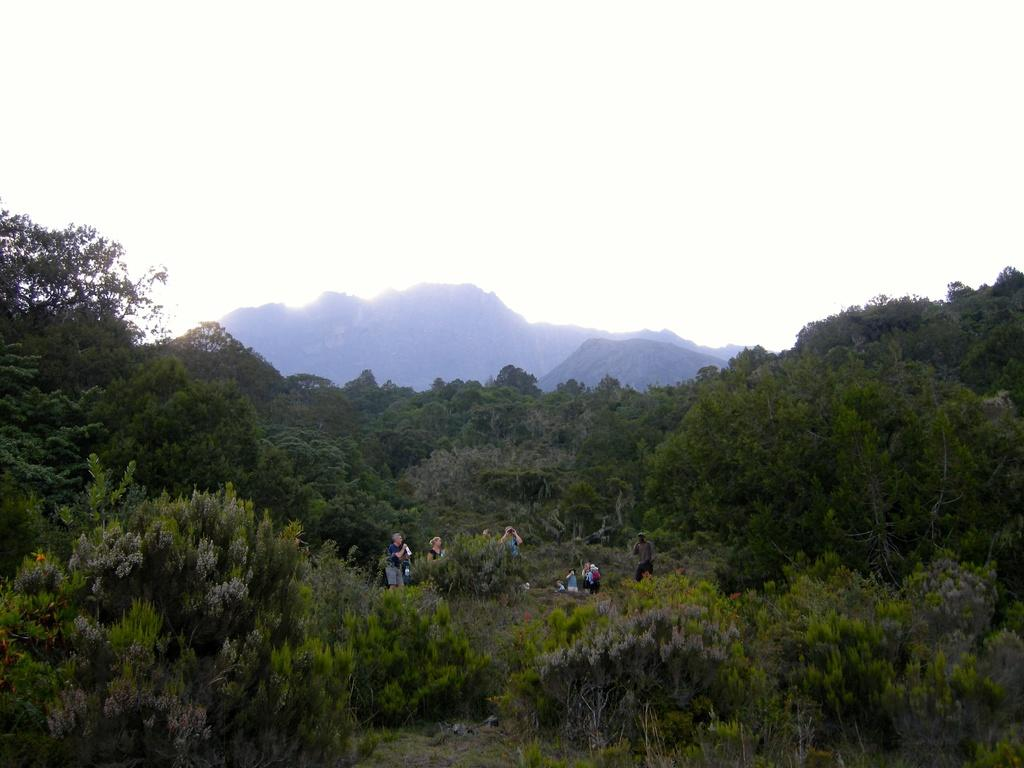What type of vegetation can be seen in the image? There are trees in the image. Can you describe the people in the image? There is a group of people in the image. What can be seen in the distance in the image? There are mountains visible in the background of the image. What color is the balloon that the group of people is holding in the image? There is no balloon present in the image. What decision did the group of people make before entering the forest in the image? There is no indication of a decision made by the group of people in the image. 